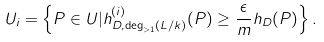Convert formula to latex. <formula><loc_0><loc_0><loc_500><loc_500>U _ { i } = \left \{ P \in U | h _ { D , \deg _ { > 1 } ( L / k ) } ^ { ( i ) } ( P ) \geq \frac { \epsilon } { m } h _ { D } ( P ) \right \} .</formula> 